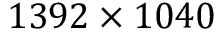Convert formula to latex. <formula><loc_0><loc_0><loc_500><loc_500>1 3 9 2 \times 1 0 4 0</formula> 